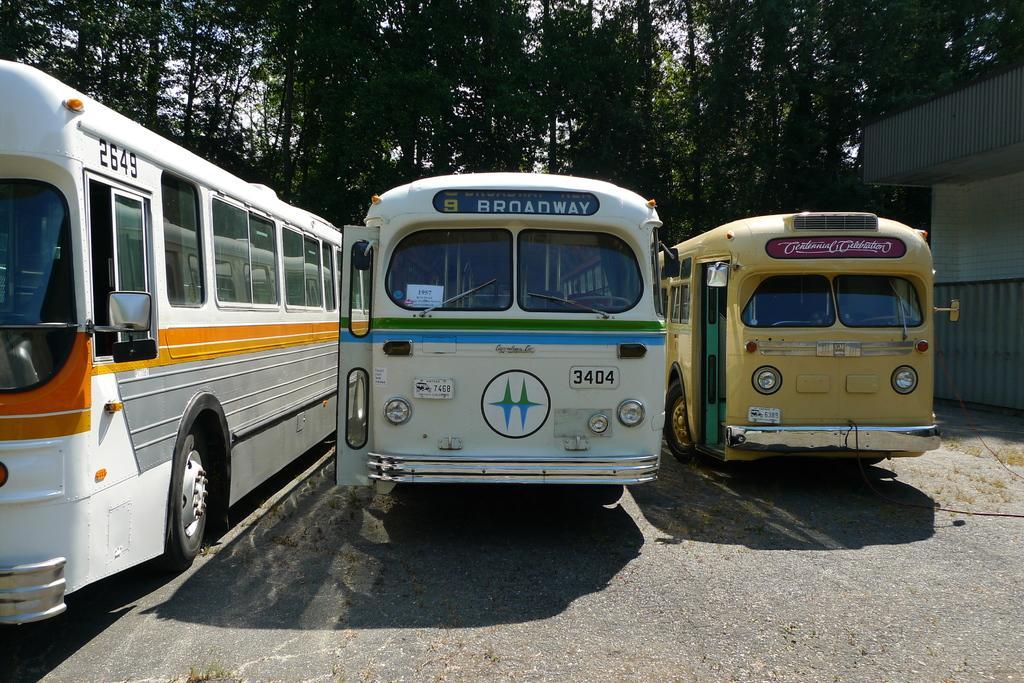Can you describe this image briefly? In this picture there are buses in the center of the image and there is a house on the right side of the image and there are trees in the background area of the image. 